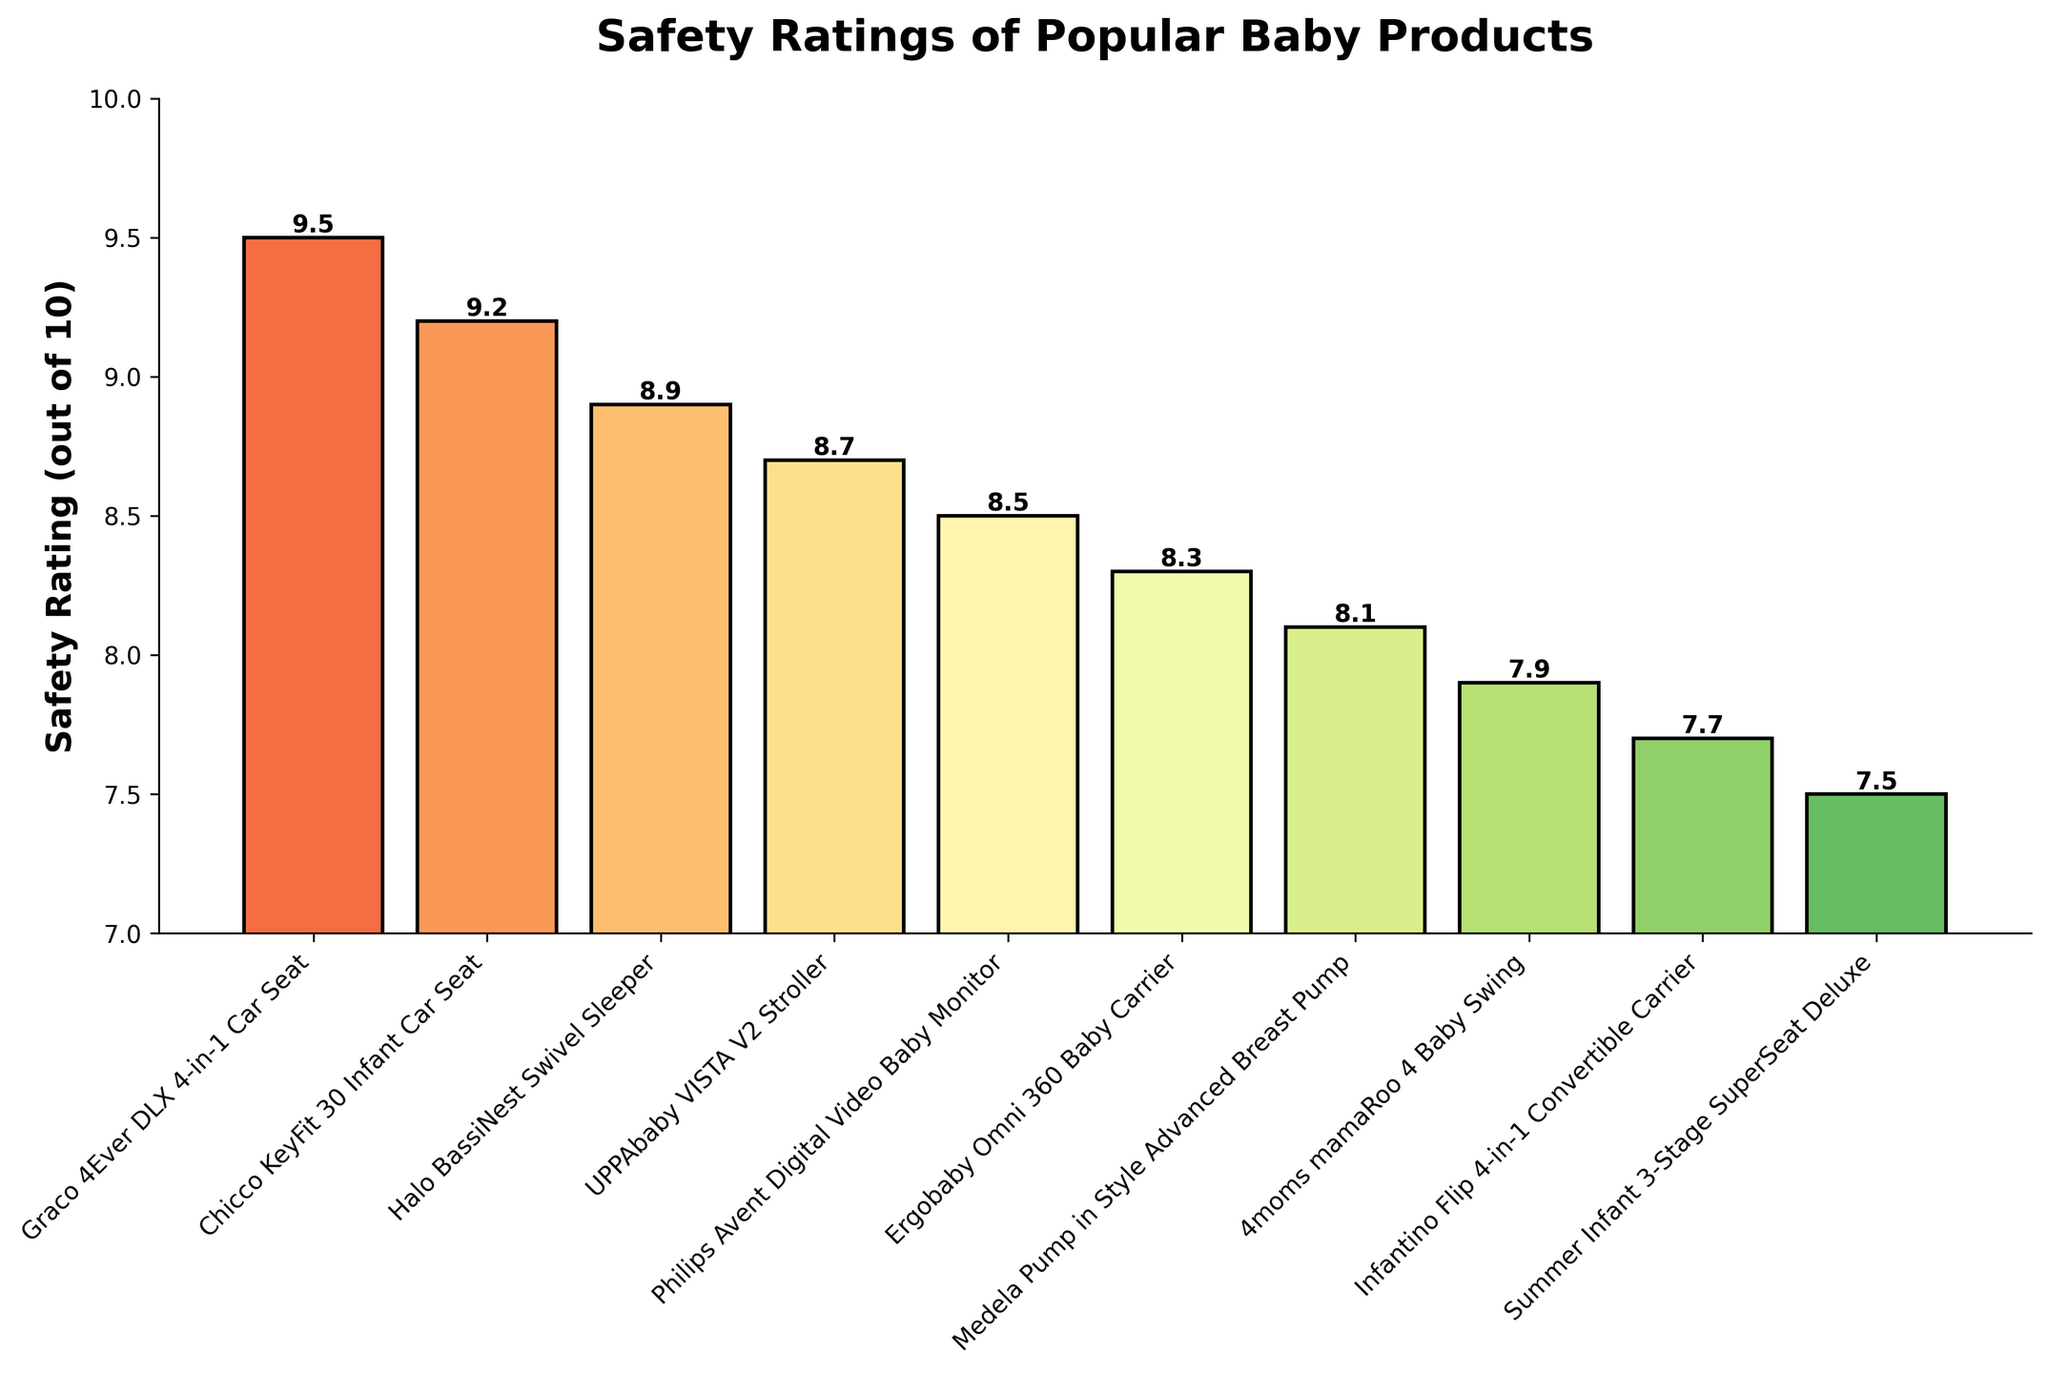Which product has the highest safety rating? The bar with the highest value indicates the product with the highest safety rating. From the chart, it is the "Graco 4Ever DLX 4-in-1 Car Seat" with a rating of 9.5.
Answer: Graco 4Ever DLX 4-in-1 Car Seat Which product has the lowest safety rating? The bar with the lowest height indicates the product with the lowest safety rating. From the chart, it is the "Summer Infant 3-Stage SuperSeat Deluxe" with a rating of 7.5.
Answer: Summer Infant 3-Stage SuperSeat Deluxe How much higher is the safety rating of the “Graco 4Ever DLX 4-in-1 Car Seat” compared to the “Summer Infant 3-Stage SuperSeat Deluxe”? Subtract the safety rating of the “Summer Infant 3-Stage SuperSeat Deluxe” (7.5) from the rating of the “Graco 4Ever DLX 4-in-1 Car Seat” (9.5). So, 9.5 - 7.5 = 2.0.
Answer: 2.0 Which two products have a difference of 0.5 in their safety ratings? Find pairs of adjacent bars whose heights differ by 0.5. Here, the "Ergobaby Omni 360 Baby Carrier" (8.3) and the "Medela Pump in Style Advanced Breast Pump" (8.1) differ by 0.2 and not 0.5. Similarly, check others until we find that the “Chicco KeyFit 30 Infant Car Seat” (9.2) and “Halo BassiNest Swivel Sleeper” (8.9) have a difference of 0.3. Upon checking, “4moms mamaRoo 4 Baby Swing” (7.9) and “Infantino Flip 4-in-1 Convertible Carrier” (7.7) differ by 0.2 as well. None exhibit a 0.5 difference.
Answer: None What's the average safety rating of all these products? Sum all the safety ratings (9.5 + 9.2 + 8.9 + 8.7 + 8.5 + 8.3 + 8.1 + 7.9 + 7.7 + 7.5) and divide by the number of products (10). Therefore, (84.3) / 10 = 8.43.
Answer: 8.43 Which product is the closest in safety rating to the “UPPAbaby VISTA V2 Stroller”? Identify the "UPPAbaby VISTA V2 Stroller" with a rating of 8.7. Then, check the safety ratings of other products to find the closest one, which is the "Halo BassiNest Swivel Sleeper" with a rating of 8.9.
Answer: Halo BassiNest Swivel Sleeper Among the products listed, how many have a safety rating greater than 8.0 but less than 9.0? Count the bars that fall in the range (8.0, 9.0). These products are "Halo BassiNest Swivel Sleeper" (8.9), "UPPAbaby VISTA V2 Stroller" (8.7), "Philips Avent Digital Video Baby Monitor" (8.5), "Ergobaby Omni 360 Baby Carrier" (8.3), and "Medela Pump in Style Advanced Breast Pump" (8.1). There are 5 products.
Answer: 5 Which products have a safety rating depicted by bars that are shorter than 8 units? Identify the bars that fall below the 8 unit mark: "4moms mamaRoo 4 Baby Swing" (7.9), "Infantino Flip 4-in-1 Convertible Carrier" (7.7), and "Summer Infant 3-Stage SuperSeat Deluxe" (7.5).
Answer: 4moms mamaRoo 4 Baby Swing, Infantino Flip 4-in-1 Convertible Carrier, Summer Infant 3-Stage SuperSeat Deluxe How much taller is the tallest bar compared to the shortest bar? The tallest bar represents the “Graco 4Ever DLX 4-in-1 Car Seat” with a height of 9.5, and the shortest bar represents the “Summer Infant 3-Stage SuperSeat Deluxe” with a height of 7.5. The difference can be calculated as 9.5 - 7.5 = 2.0.
Answer: 2.0 